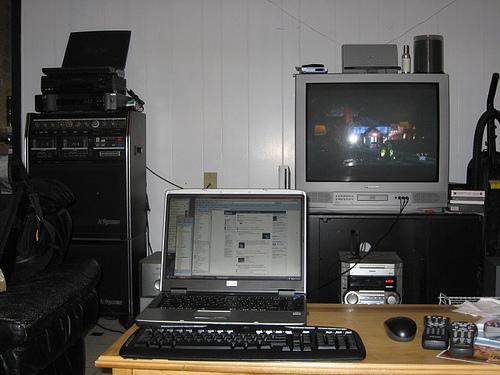How many keyboards are they?
Keep it brief. 2. How bright is the laptop?
Short answer required. Bright. Where is the mouse?
Answer briefly. Table. Are there any windows open?
Concise answer only. Yes. What is to the left?
Answer briefly. Stereo. What is the tall object to the left of the TV?
Give a very brief answer. Speaker. Can you see out the window?
Answer briefly. No. What website is on the computer screen?
Short answer required. Facebook. Is there power in this room?
Give a very brief answer. Yes. Where are the speakers?
Write a very short answer. Floor. How many TVs are there?
Be succinct. 1. What color is the computer mouse?
Concise answer only. Black. 